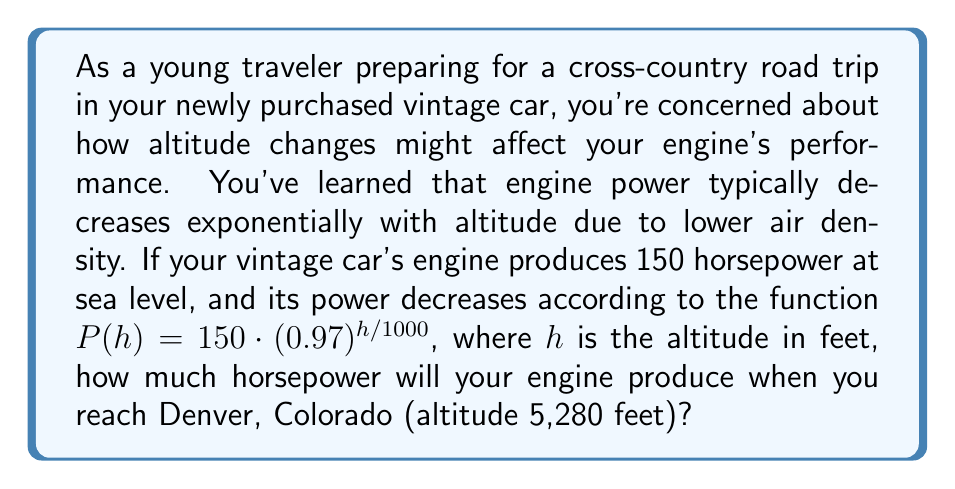Can you answer this question? To solve this problem, we need to use the given exponential function and plug in the altitude of Denver. Let's break it down step-by-step:

1. The given function is:
   $P(h) = 150 \cdot (0.97)^{h/1000}$

   Where:
   - $P(h)$ is the power at altitude $h$
   - 150 is the sea-level horsepower
   - 0.97 is the base of the exponential function
   - $h$ is the altitude in feet

2. We need to find $P(5280)$ since Denver's altitude is 5,280 feet.

3. Let's substitute $h = 5280$ into the function:
   $P(5280) = 150 \cdot (0.97)^{5280/1000}$

4. Simplify the exponent:
   $P(5280) = 150 \cdot (0.97)^{5.28}$

5. Calculate the exponential part:
   $(0.97)^{5.28} \approx 0.8516$ (rounded to 4 decimal places)

6. Multiply by 150:
   $P(5280) = 150 \cdot 0.8516 \approx 127.74$ horsepower

Therefore, your vintage car's engine will produce approximately 127.74 horsepower in Denver.
Answer: 127.74 horsepower (rounded to 2 decimal places) 